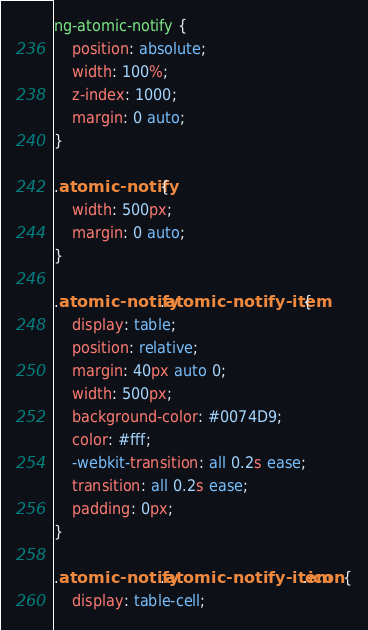<code> <loc_0><loc_0><loc_500><loc_500><_CSS_>ng-atomic-notify {
    position: absolute;
    width: 100%;
    z-index: 1000;
    margin: 0 auto;
}

.atomic-notify {
    width: 500px;
    margin: 0 auto;
}

.atomic-notify .atomic-notify-item {
    display: table;
    position: relative;
    margin: 40px auto 0;
    width: 500px;
    background-color: #0074D9;
    color: #fff;
    -webkit-transition: all 0.2s ease;
    transition: all 0.2s ease;
    padding: 0px;
}

.atomic-notify .atomic-notify-item .icon {
    display: table-cell;</code> 